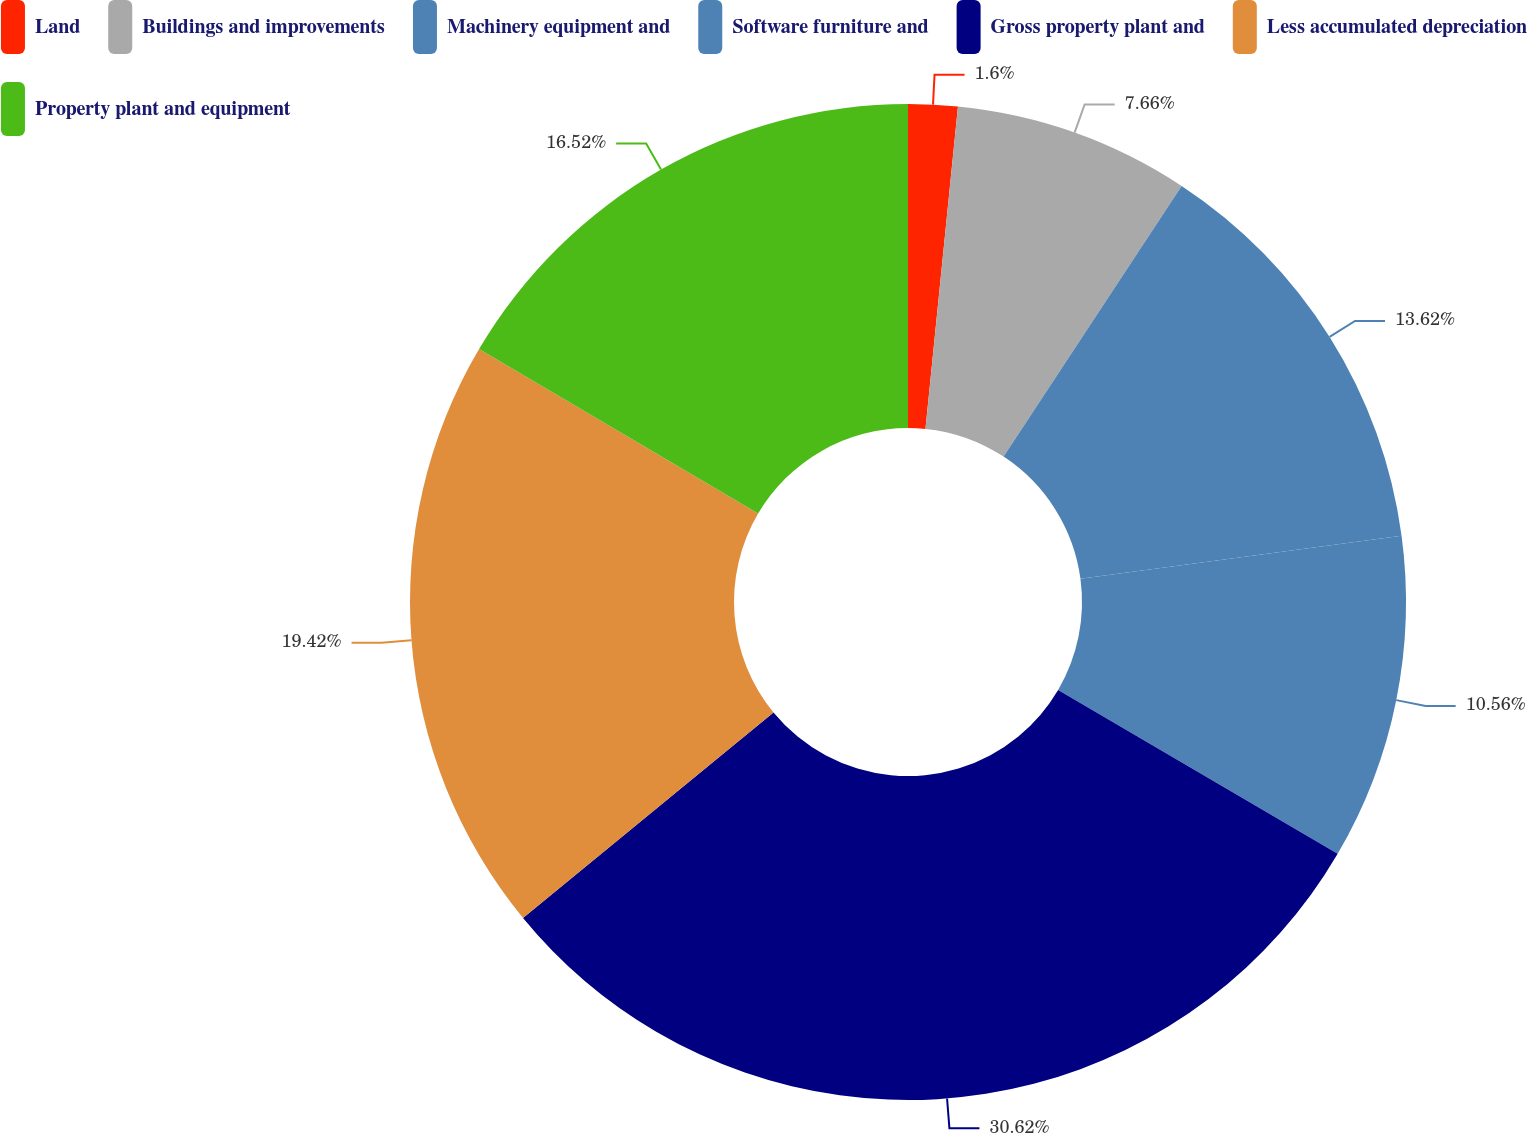<chart> <loc_0><loc_0><loc_500><loc_500><pie_chart><fcel>Land<fcel>Buildings and improvements<fcel>Machinery equipment and<fcel>Software furniture and<fcel>Gross property plant and<fcel>Less accumulated depreciation<fcel>Property plant and equipment<nl><fcel>1.6%<fcel>7.66%<fcel>13.62%<fcel>10.56%<fcel>30.63%<fcel>19.42%<fcel>16.52%<nl></chart> 